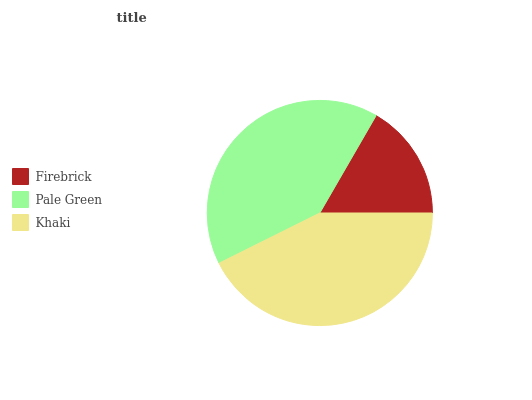Is Firebrick the minimum?
Answer yes or no. Yes. Is Khaki the maximum?
Answer yes or no. Yes. Is Pale Green the minimum?
Answer yes or no. No. Is Pale Green the maximum?
Answer yes or no. No. Is Pale Green greater than Firebrick?
Answer yes or no. Yes. Is Firebrick less than Pale Green?
Answer yes or no. Yes. Is Firebrick greater than Pale Green?
Answer yes or no. No. Is Pale Green less than Firebrick?
Answer yes or no. No. Is Pale Green the high median?
Answer yes or no. Yes. Is Pale Green the low median?
Answer yes or no. Yes. Is Khaki the high median?
Answer yes or no. No. Is Firebrick the low median?
Answer yes or no. No. 